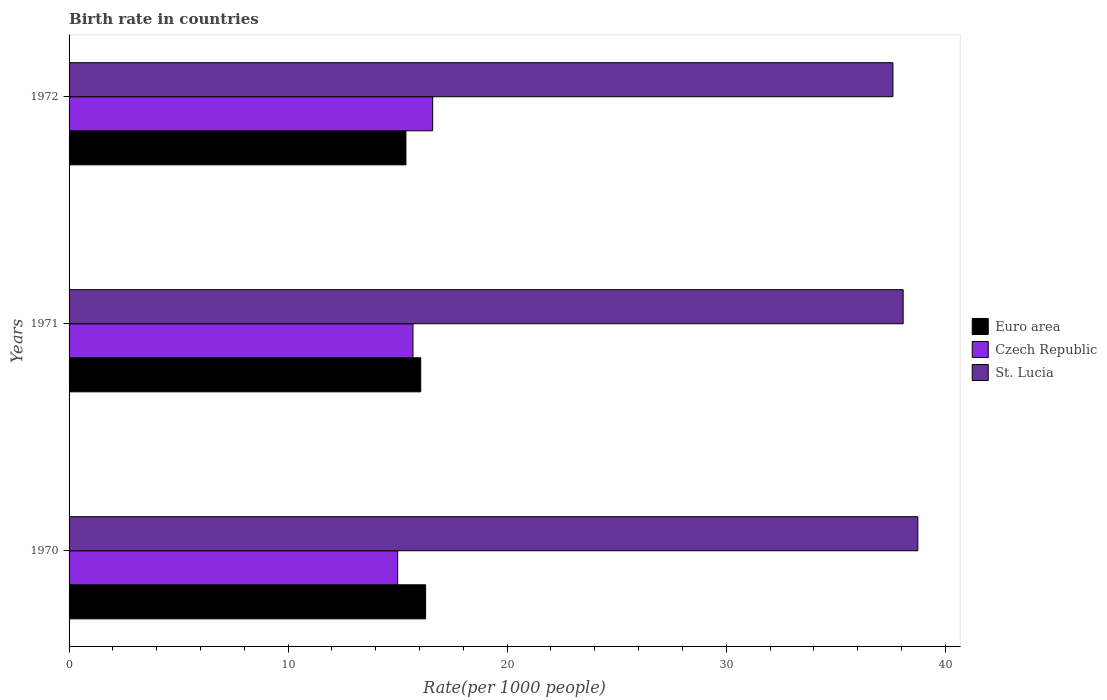Are the number of bars per tick equal to the number of legend labels?
Your answer should be compact. Yes. Are the number of bars on each tick of the Y-axis equal?
Your answer should be compact. Yes. How many bars are there on the 1st tick from the top?
Your answer should be compact. 3. How many bars are there on the 3rd tick from the bottom?
Your answer should be very brief. 3. In how many cases, is the number of bars for a given year not equal to the number of legend labels?
Provide a succinct answer. 0. What is the birth rate in St. Lucia in 1971?
Your answer should be compact. 38.08. Across all years, what is the minimum birth rate in Euro area?
Your response must be concise. 15.38. In which year was the birth rate in St. Lucia minimum?
Provide a short and direct response. 1972. What is the total birth rate in St. Lucia in the graph?
Offer a terse response. 114.44. What is the difference between the birth rate in Czech Republic in 1971 and that in 1972?
Provide a short and direct response. -0.9. What is the difference between the birth rate in Euro area in 1970 and the birth rate in St. Lucia in 1972?
Give a very brief answer. -21.33. What is the average birth rate in St. Lucia per year?
Keep it short and to the point. 38.15. In the year 1972, what is the difference between the birth rate in Euro area and birth rate in Czech Republic?
Your response must be concise. -1.22. In how many years, is the birth rate in St. Lucia greater than 22 ?
Provide a succinct answer. 3. What is the ratio of the birth rate in Euro area in 1971 to that in 1972?
Give a very brief answer. 1.04. What is the difference between the highest and the second highest birth rate in Czech Republic?
Ensure brevity in your answer.  0.9. What is the difference between the highest and the lowest birth rate in Euro area?
Your answer should be compact. 0.9. In how many years, is the birth rate in Euro area greater than the average birth rate in Euro area taken over all years?
Give a very brief answer. 2. Is the sum of the birth rate in Euro area in 1970 and 1972 greater than the maximum birth rate in St. Lucia across all years?
Ensure brevity in your answer.  No. What does the 1st bar from the top in 1971 represents?
Ensure brevity in your answer.  St. Lucia. What does the 3rd bar from the bottom in 1971 represents?
Your answer should be very brief. St. Lucia. What is the difference between two consecutive major ticks on the X-axis?
Ensure brevity in your answer.  10. Does the graph contain grids?
Ensure brevity in your answer.  No. Where does the legend appear in the graph?
Give a very brief answer. Center right. How are the legend labels stacked?
Ensure brevity in your answer.  Vertical. What is the title of the graph?
Your answer should be compact. Birth rate in countries. What is the label or title of the X-axis?
Make the answer very short. Rate(per 1000 people). What is the label or title of the Y-axis?
Offer a terse response. Years. What is the Rate(per 1000 people) in Euro area in 1970?
Your answer should be very brief. 16.28. What is the Rate(per 1000 people) in St. Lucia in 1970?
Provide a succinct answer. 38.75. What is the Rate(per 1000 people) of Euro area in 1971?
Your answer should be very brief. 16.05. What is the Rate(per 1000 people) of Czech Republic in 1971?
Ensure brevity in your answer.  15.7. What is the Rate(per 1000 people) of St. Lucia in 1971?
Provide a succinct answer. 38.08. What is the Rate(per 1000 people) of Euro area in 1972?
Your response must be concise. 15.38. What is the Rate(per 1000 people) of Czech Republic in 1972?
Provide a short and direct response. 16.6. What is the Rate(per 1000 people) in St. Lucia in 1972?
Ensure brevity in your answer.  37.61. Across all years, what is the maximum Rate(per 1000 people) in Euro area?
Keep it short and to the point. 16.28. Across all years, what is the maximum Rate(per 1000 people) of St. Lucia?
Give a very brief answer. 38.75. Across all years, what is the minimum Rate(per 1000 people) of Euro area?
Your response must be concise. 15.38. Across all years, what is the minimum Rate(per 1000 people) of St. Lucia?
Your answer should be compact. 37.61. What is the total Rate(per 1000 people) in Euro area in the graph?
Offer a very short reply. 47.71. What is the total Rate(per 1000 people) of Czech Republic in the graph?
Keep it short and to the point. 47.3. What is the total Rate(per 1000 people) in St. Lucia in the graph?
Your answer should be compact. 114.44. What is the difference between the Rate(per 1000 people) in Euro area in 1970 and that in 1971?
Your answer should be very brief. 0.22. What is the difference between the Rate(per 1000 people) in Czech Republic in 1970 and that in 1971?
Keep it short and to the point. -0.7. What is the difference between the Rate(per 1000 people) in St. Lucia in 1970 and that in 1971?
Ensure brevity in your answer.  0.67. What is the difference between the Rate(per 1000 people) in Euro area in 1970 and that in 1972?
Offer a very short reply. 0.9. What is the difference between the Rate(per 1000 people) in St. Lucia in 1970 and that in 1972?
Your answer should be compact. 1.14. What is the difference between the Rate(per 1000 people) in Euro area in 1971 and that in 1972?
Provide a succinct answer. 0.68. What is the difference between the Rate(per 1000 people) in St. Lucia in 1971 and that in 1972?
Offer a terse response. 0.47. What is the difference between the Rate(per 1000 people) of Euro area in 1970 and the Rate(per 1000 people) of Czech Republic in 1971?
Provide a short and direct response. 0.58. What is the difference between the Rate(per 1000 people) of Euro area in 1970 and the Rate(per 1000 people) of St. Lucia in 1971?
Your answer should be very brief. -21.8. What is the difference between the Rate(per 1000 people) in Czech Republic in 1970 and the Rate(per 1000 people) in St. Lucia in 1971?
Make the answer very short. -23.08. What is the difference between the Rate(per 1000 people) of Euro area in 1970 and the Rate(per 1000 people) of Czech Republic in 1972?
Make the answer very short. -0.32. What is the difference between the Rate(per 1000 people) of Euro area in 1970 and the Rate(per 1000 people) of St. Lucia in 1972?
Make the answer very short. -21.33. What is the difference between the Rate(per 1000 people) in Czech Republic in 1970 and the Rate(per 1000 people) in St. Lucia in 1972?
Your answer should be very brief. -22.61. What is the difference between the Rate(per 1000 people) of Euro area in 1971 and the Rate(per 1000 people) of Czech Republic in 1972?
Your response must be concise. -0.55. What is the difference between the Rate(per 1000 people) in Euro area in 1971 and the Rate(per 1000 people) in St. Lucia in 1972?
Provide a short and direct response. -21.56. What is the difference between the Rate(per 1000 people) in Czech Republic in 1971 and the Rate(per 1000 people) in St. Lucia in 1972?
Provide a succinct answer. -21.91. What is the average Rate(per 1000 people) in Euro area per year?
Make the answer very short. 15.9. What is the average Rate(per 1000 people) in Czech Republic per year?
Give a very brief answer. 15.77. What is the average Rate(per 1000 people) of St. Lucia per year?
Ensure brevity in your answer.  38.15. In the year 1970, what is the difference between the Rate(per 1000 people) in Euro area and Rate(per 1000 people) in Czech Republic?
Provide a succinct answer. 1.28. In the year 1970, what is the difference between the Rate(per 1000 people) of Euro area and Rate(per 1000 people) of St. Lucia?
Make the answer very short. -22.47. In the year 1970, what is the difference between the Rate(per 1000 people) of Czech Republic and Rate(per 1000 people) of St. Lucia?
Your response must be concise. -23.75. In the year 1971, what is the difference between the Rate(per 1000 people) in Euro area and Rate(per 1000 people) in Czech Republic?
Offer a terse response. 0.35. In the year 1971, what is the difference between the Rate(per 1000 people) of Euro area and Rate(per 1000 people) of St. Lucia?
Give a very brief answer. -22.02. In the year 1971, what is the difference between the Rate(per 1000 people) of Czech Republic and Rate(per 1000 people) of St. Lucia?
Provide a succinct answer. -22.38. In the year 1972, what is the difference between the Rate(per 1000 people) in Euro area and Rate(per 1000 people) in Czech Republic?
Provide a short and direct response. -1.22. In the year 1972, what is the difference between the Rate(per 1000 people) in Euro area and Rate(per 1000 people) in St. Lucia?
Your answer should be compact. -22.23. In the year 1972, what is the difference between the Rate(per 1000 people) in Czech Republic and Rate(per 1000 people) in St. Lucia?
Ensure brevity in your answer.  -21.01. What is the ratio of the Rate(per 1000 people) in Euro area in 1970 to that in 1971?
Ensure brevity in your answer.  1.01. What is the ratio of the Rate(per 1000 people) of Czech Republic in 1970 to that in 1971?
Your answer should be very brief. 0.96. What is the ratio of the Rate(per 1000 people) in St. Lucia in 1970 to that in 1971?
Make the answer very short. 1.02. What is the ratio of the Rate(per 1000 people) in Euro area in 1970 to that in 1972?
Provide a succinct answer. 1.06. What is the ratio of the Rate(per 1000 people) in Czech Republic in 1970 to that in 1972?
Provide a succinct answer. 0.9. What is the ratio of the Rate(per 1000 people) of St. Lucia in 1970 to that in 1972?
Give a very brief answer. 1.03. What is the ratio of the Rate(per 1000 people) in Euro area in 1971 to that in 1972?
Keep it short and to the point. 1.04. What is the ratio of the Rate(per 1000 people) in Czech Republic in 1971 to that in 1972?
Your answer should be compact. 0.95. What is the ratio of the Rate(per 1000 people) of St. Lucia in 1971 to that in 1972?
Keep it short and to the point. 1.01. What is the difference between the highest and the second highest Rate(per 1000 people) in Euro area?
Keep it short and to the point. 0.22. What is the difference between the highest and the second highest Rate(per 1000 people) of St. Lucia?
Provide a short and direct response. 0.67. What is the difference between the highest and the lowest Rate(per 1000 people) of Euro area?
Offer a terse response. 0.9. What is the difference between the highest and the lowest Rate(per 1000 people) of Czech Republic?
Offer a terse response. 1.6. What is the difference between the highest and the lowest Rate(per 1000 people) of St. Lucia?
Ensure brevity in your answer.  1.14. 